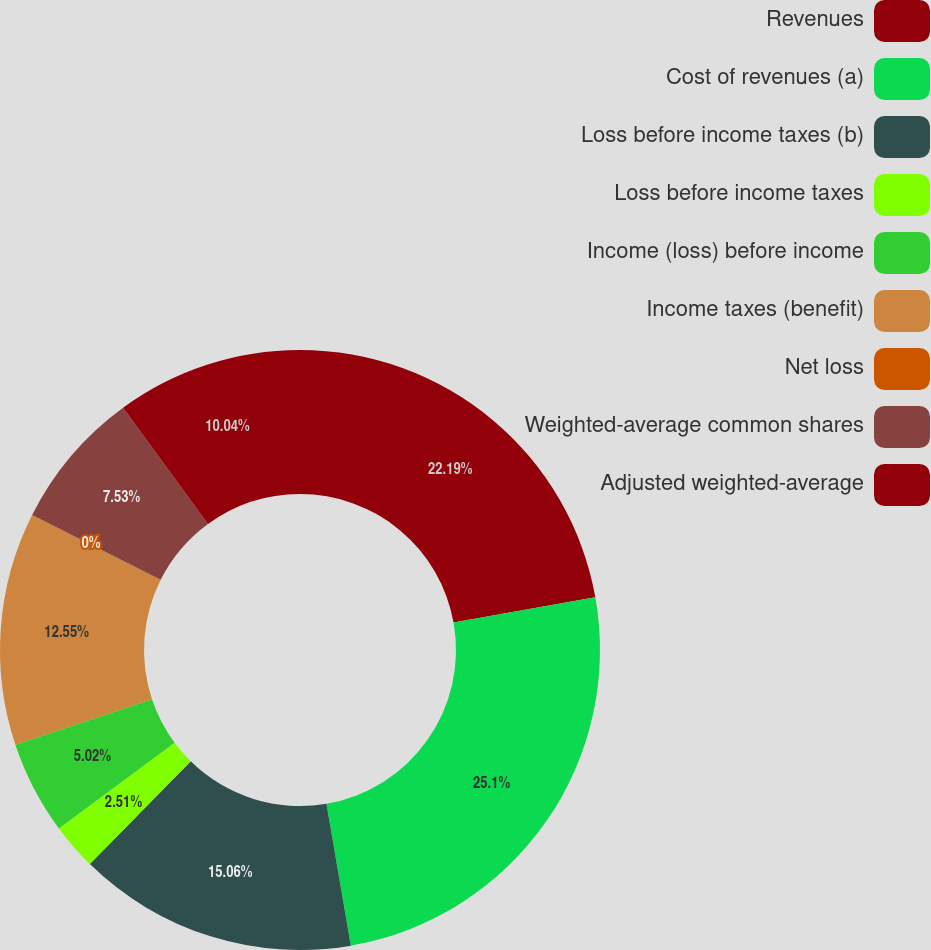Convert chart. <chart><loc_0><loc_0><loc_500><loc_500><pie_chart><fcel>Revenues<fcel>Cost of revenues (a)<fcel>Loss before income taxes (b)<fcel>Loss before income taxes<fcel>Income (loss) before income<fcel>Income taxes (benefit)<fcel>Net loss<fcel>Weighted-average common shares<fcel>Adjusted weighted-average<nl><fcel>22.19%<fcel>25.1%<fcel>15.06%<fcel>2.51%<fcel>5.02%<fcel>12.55%<fcel>0.0%<fcel>7.53%<fcel>10.04%<nl></chart> 